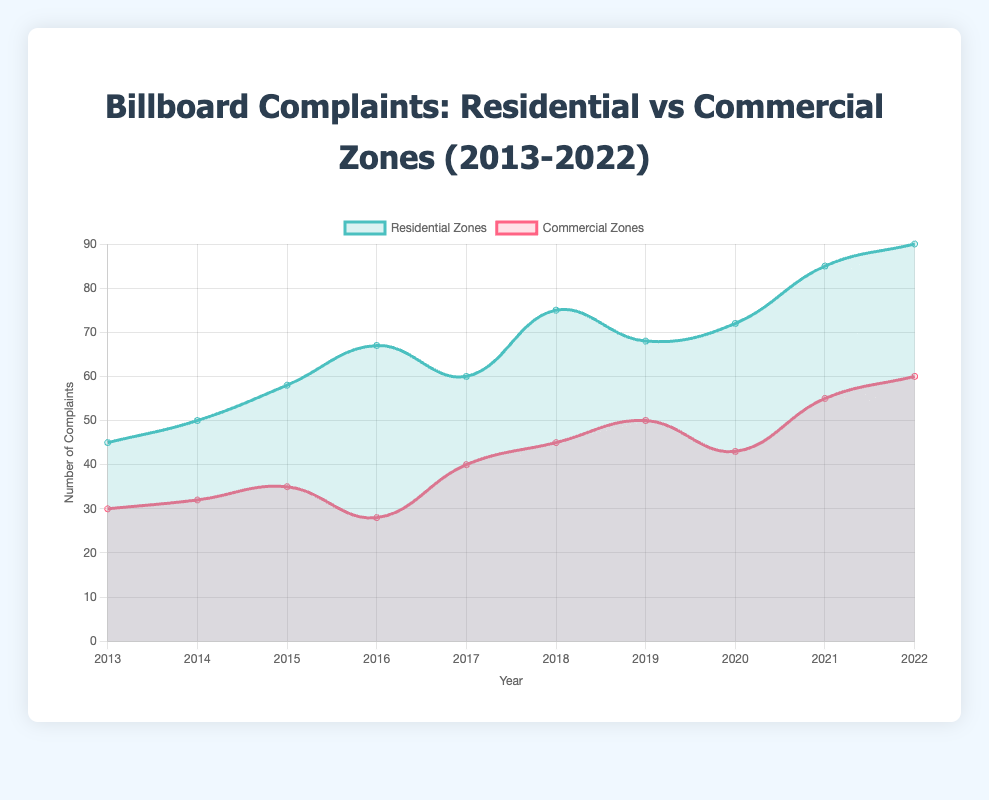How many complaints were reported in residential zones in 2016? By looking at the points for residential zones in 2016, the chart shows 67 complaints.
Answer: 67 Which year had the highest number of complaints in commercial zones? By examining the peak value in the line representing commercial zones, 2022 had the highest number of complaints at 60.
Answer: 2022 What is the difference in the number of complaints between residential and commercial zones in 2015? Check the values for both zones in 2015: 58 for residential and 35 for commercial. The difference is 58 - 35 = 23.
Answer: 23 How many more complaints were there in residential zones compared to commercial zones in 2020? Checking the values for 2020, there were 72 complaints in residential zones and 43 in commercial zones. The difference is 72 - 43 = 29.
Answer: 29 What is the average number of complaints in commercial zones over the decade? Sum all the complaints for commercial zones (30 + 32 + 35 + 28 + 40 + 45 + 50 + 43 + 55 + 60) = 418. Divide by the 10 years: 418 / 10 = 41.8.
Answer: 41.8 Which zone, residential or commercial, had a larger increase in complaints from 2013 to 2022? Complaints in residential zones increased from 45 in 2013 to 90 in 2022, which is an increase of 45. Complaints in commercial zones increased from 30 in 2013 to 60 in 2022, which is an increase of 30. So, the residential zone had a larger increase.
Answer: Residential In which year did both residential and commercial zones experience a decrease in complaints compared to the previous year? Both zones saw a decrease from 2016 to 2017; residential complaints went from 67 to 60, and commercial complaints went from 35 to 28.
Answer: 2017 What are the key locations associated with the peak year of complaints for residential zones? The peak year for residential zone complaints is 2022 with the key location being Hillcrest.
Answer: Hillcrest How many years did residential zones have more complaints than commercial zones? By comparing each year individually, in every year from 2013 to 2022, residential zones had more complaints than commercial zones, totaling 10 years.
Answer: 10 